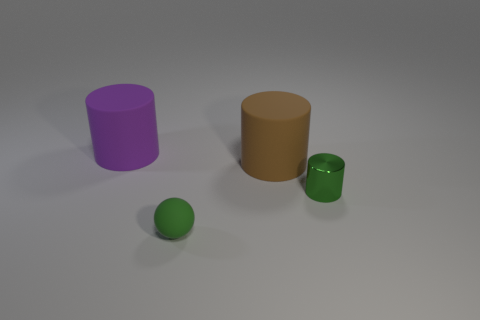Is the shape of the small metallic object behind the sphere the same as  the large purple thing?
Keep it short and to the point. Yes. What number of things are either big purple things or objects left of the small green shiny cylinder?
Ensure brevity in your answer.  3. Is the number of big purple shiny objects less than the number of tiny cylinders?
Your answer should be very brief. Yes. Is the number of large brown rubber blocks greater than the number of small green rubber things?
Offer a terse response. No. How many other things are the same material as the green cylinder?
Make the answer very short. 0. What number of metallic cylinders are in front of the rubber object that is in front of the large thing right of the big purple thing?
Your answer should be very brief. 0. How many matte things are cyan cubes or brown things?
Offer a very short reply. 1. There is a object on the right side of the big cylinder that is to the right of the purple matte cylinder; what size is it?
Offer a very short reply. Small. There is a tiny thing that is in front of the tiny shiny thing; is its color the same as the rubber cylinder on the right side of the purple matte thing?
Provide a succinct answer. No. There is a cylinder that is on the right side of the purple cylinder and on the left side of the green cylinder; what is its color?
Give a very brief answer. Brown. 